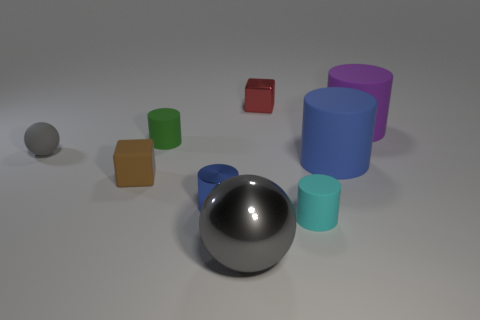Subtract all tiny shiny cylinders. How many cylinders are left? 4 Add 1 tiny purple rubber cylinders. How many objects exist? 10 Subtract all large yellow balls. Subtract all shiny cylinders. How many objects are left? 8 Add 3 cyan objects. How many cyan objects are left? 4 Add 9 gray metallic objects. How many gray metallic objects exist? 10 Subtract all blue cylinders. How many cylinders are left? 3 Subtract 0 red spheres. How many objects are left? 9 Subtract all blocks. How many objects are left? 7 Subtract 2 cylinders. How many cylinders are left? 3 Subtract all cyan cylinders. Subtract all green cubes. How many cylinders are left? 4 